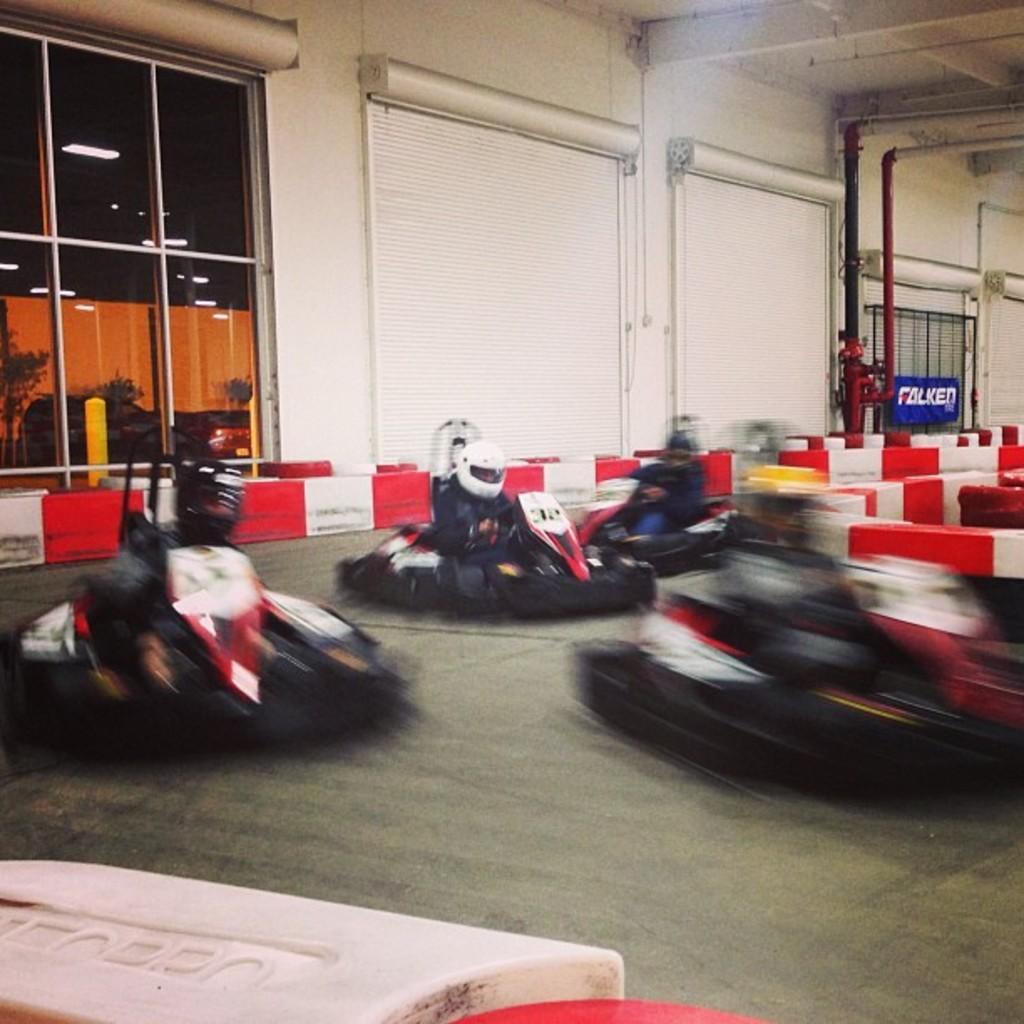Could you give a brief overview of what you see in this image? In the center of the image there are people go-karting. In the background of the image there is wall. There is glass through which we can see cars, plants. To the right side of the image there is a pipe. At the top of the image there is ceiling. At the bottom of the image there are safety barriers. 